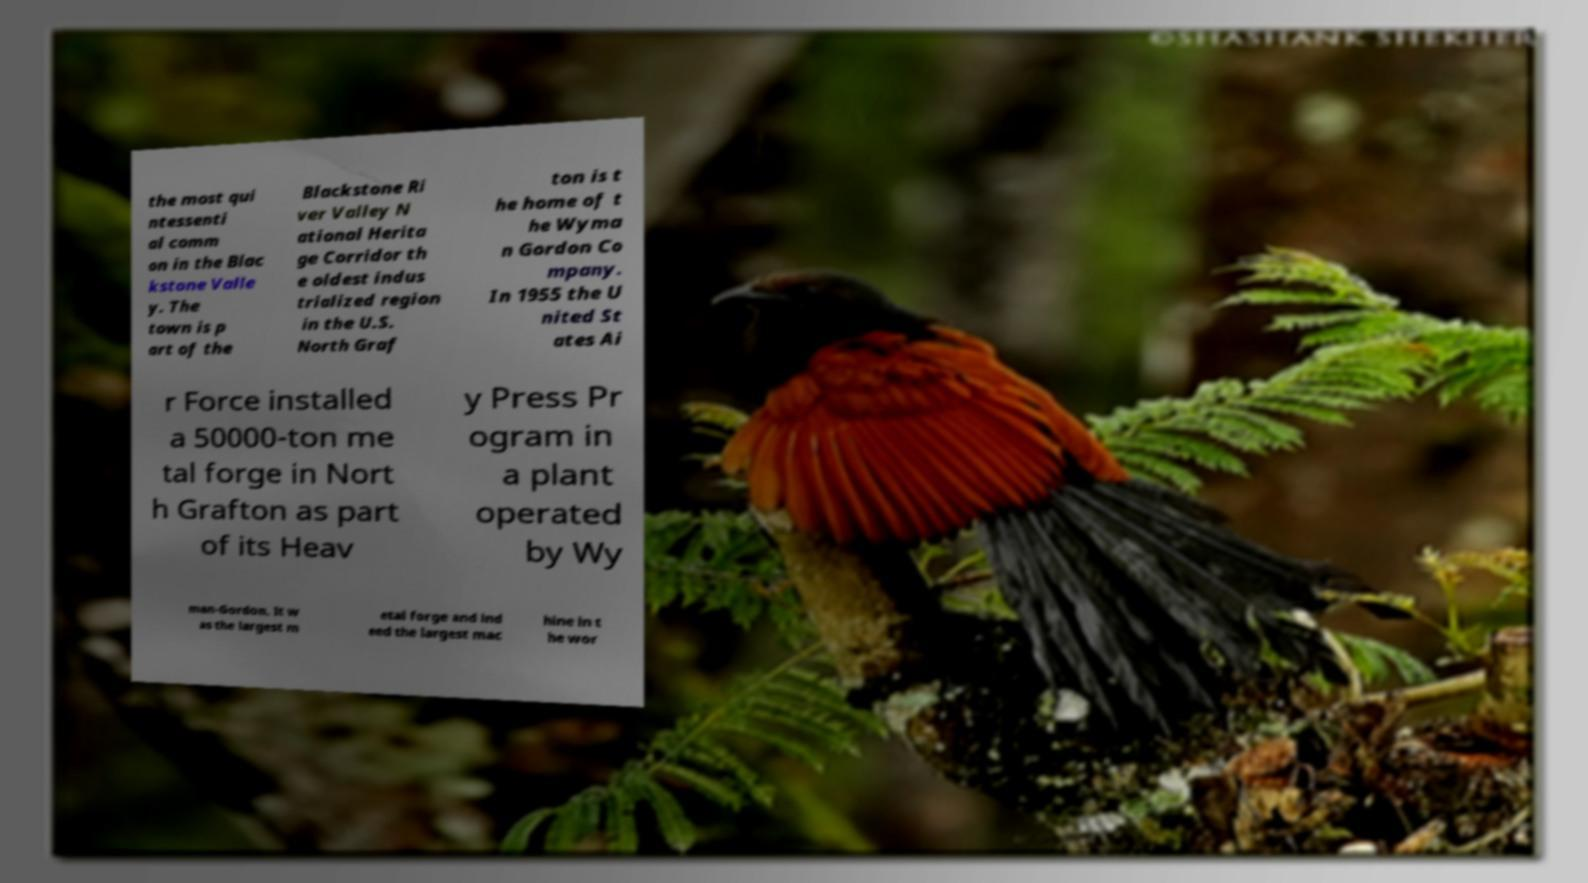For documentation purposes, I need the text within this image transcribed. Could you provide that? the most qui ntessenti al comm on in the Blac kstone Valle y. The town is p art of the Blackstone Ri ver Valley N ational Herita ge Corridor th e oldest indus trialized region in the U.S. North Graf ton is t he home of t he Wyma n Gordon Co mpany. In 1955 the U nited St ates Ai r Force installed a 50000-ton me tal forge in Nort h Grafton as part of its Heav y Press Pr ogram in a plant operated by Wy man-Gordon. It w as the largest m etal forge and ind eed the largest mac hine in t he wor 